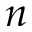<formula> <loc_0><loc_0><loc_500><loc_500>n</formula> 